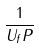Convert formula to latex. <formula><loc_0><loc_0><loc_500><loc_500>\frac { 1 } { U _ { f } P }</formula> 